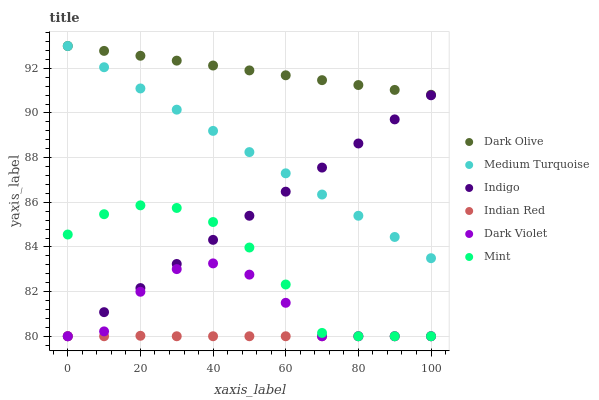Does Indian Red have the minimum area under the curve?
Answer yes or no. Yes. Does Dark Olive have the maximum area under the curve?
Answer yes or no. Yes. Does Medium Turquoise have the minimum area under the curve?
Answer yes or no. No. Does Medium Turquoise have the maximum area under the curve?
Answer yes or no. No. Is Indigo the smoothest?
Answer yes or no. Yes. Is Dark Violet the roughest?
Answer yes or no. Yes. Is Medium Turquoise the smoothest?
Answer yes or no. No. Is Medium Turquoise the roughest?
Answer yes or no. No. Does Indigo have the lowest value?
Answer yes or no. Yes. Does Medium Turquoise have the lowest value?
Answer yes or no. No. Does Dark Olive have the highest value?
Answer yes or no. Yes. Does Dark Violet have the highest value?
Answer yes or no. No. Is Indian Red less than Dark Olive?
Answer yes or no. Yes. Is Medium Turquoise greater than Indian Red?
Answer yes or no. Yes. Does Indigo intersect Dark Violet?
Answer yes or no. Yes. Is Indigo less than Dark Violet?
Answer yes or no. No. Is Indigo greater than Dark Violet?
Answer yes or no. No. Does Indian Red intersect Dark Olive?
Answer yes or no. No. 